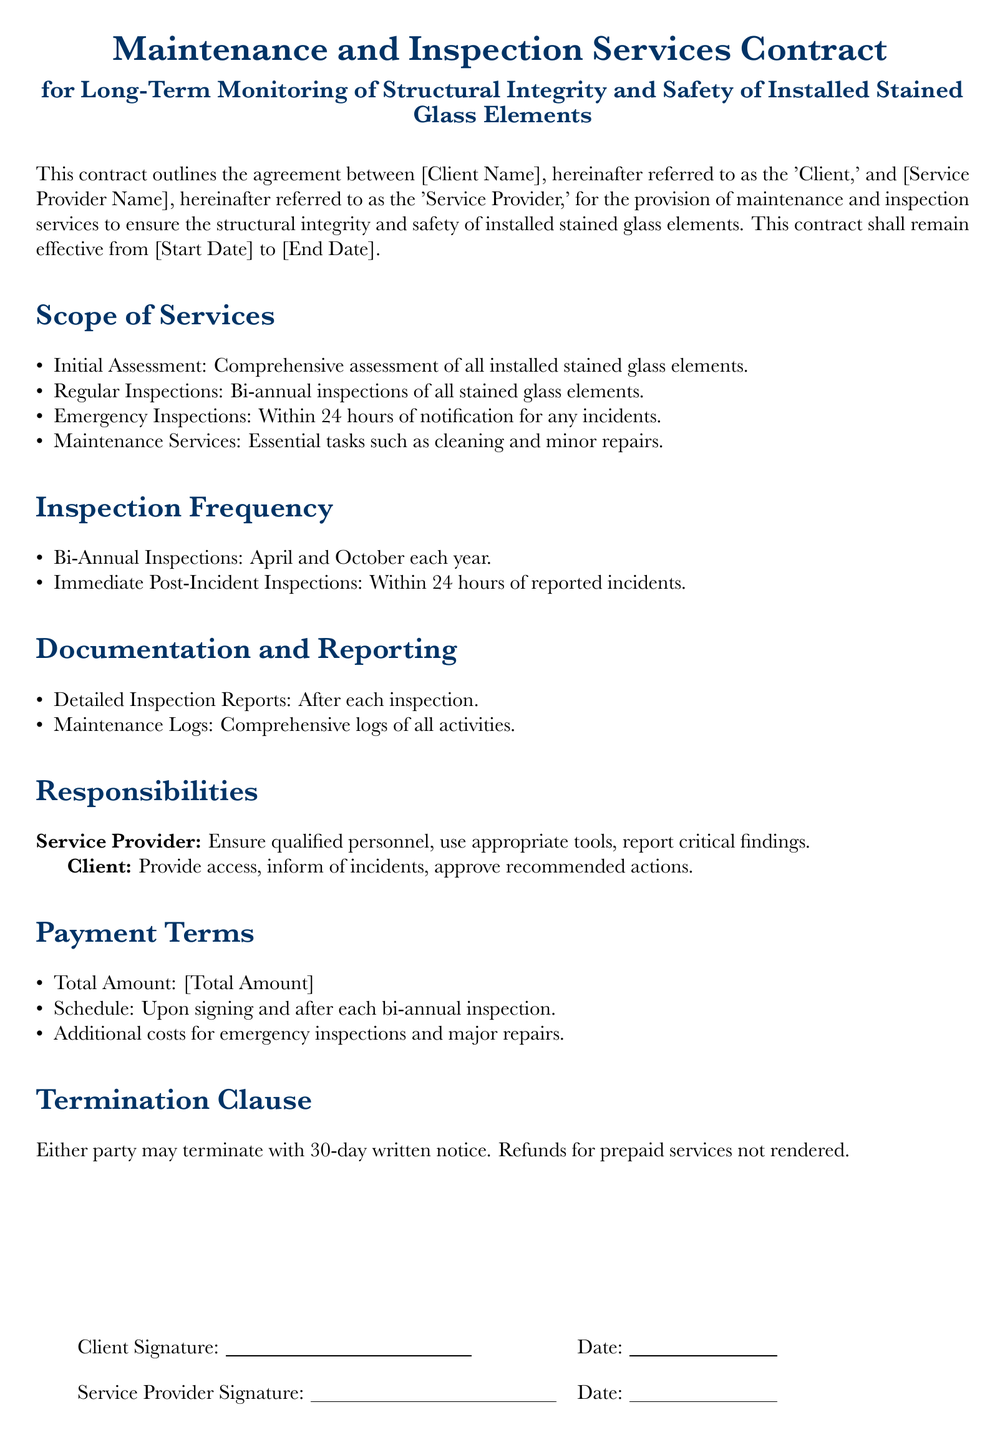What is the Client's role in the contract? The Client is responsible for providing access, informing of incidents, and approving recommended actions.
Answer: Provide access, inform of incidents, approve recommended actions How often will regular inspections occur? The document states that regular inspections will happen bi-annually.
Answer: Bi-annual inspections What is the timing of the Bi-Annual Inspections? It specifies that inspections will take place in April and October each year.
Answer: April and October What kind of inspections occur after an incident? The contract requires immediate post-incident inspections within 24 hours of reported incidents.
Answer: Within 24 hours What should the Service Provider ensure regarding personnel? The Service Provider must ensure that qualified personnel are used for the services.
Answer: Ensure qualified personnel What is included in the Maintenance Services? The scope of services mentions essential tasks such as cleaning and minor repairs.
Answer: Cleaning and minor repairs What is the notice period for termination of the contract? A 30-day written notice is required for termination by either party.
Answer: 30-day written notice What is the payment schedule mentioned in the contract? Payments are due upon signing and after each bi-annual inspection.
Answer: Upon signing and after each bi-annual inspection What type of reports are generated after inspections? The contract requires detailed inspection reports to be provided after each inspection.
Answer: Detailed Inspection Reports 